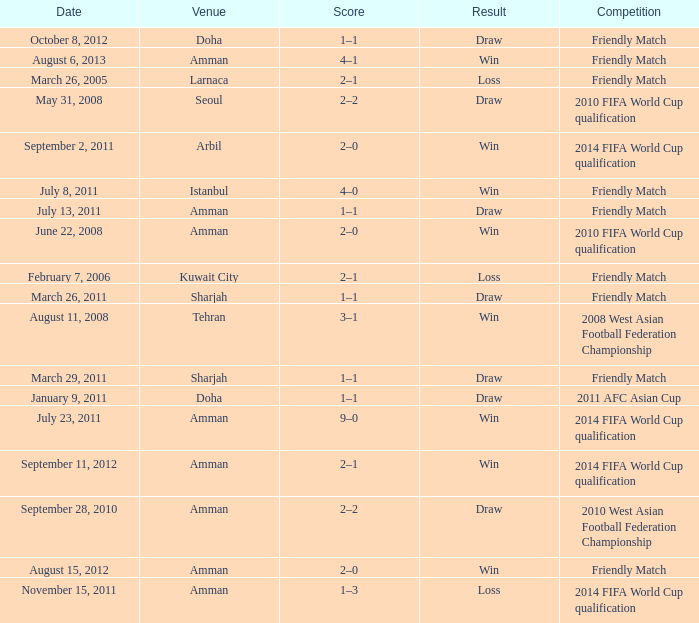WHat was the result of the friendly match that was played on october 8, 2012? Draw. 